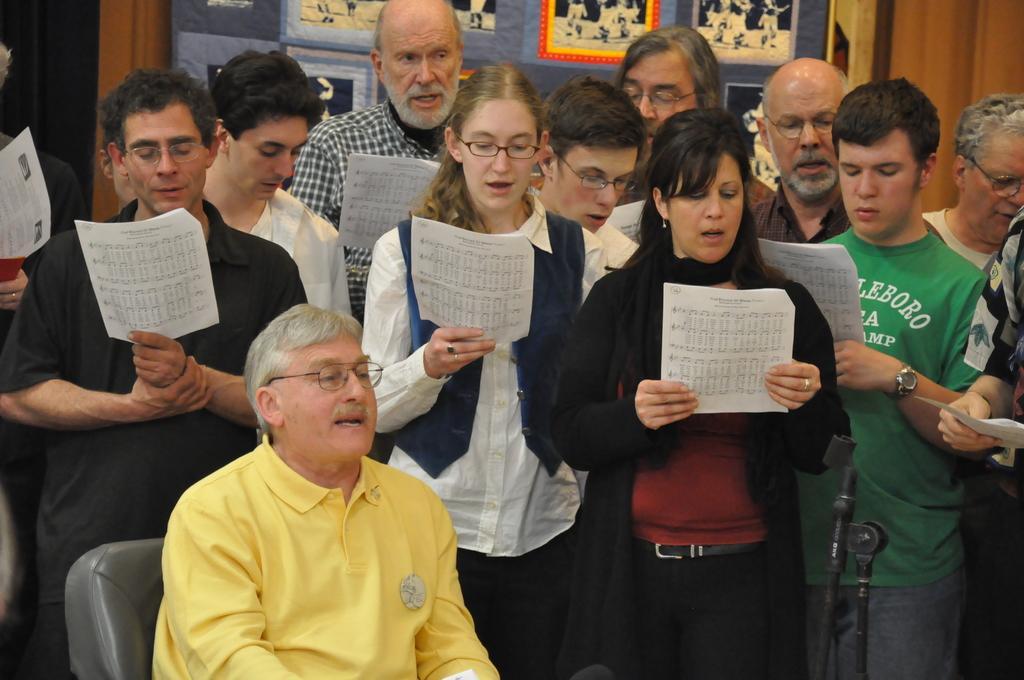Please provide a concise description of this image. In this image, there are a few people. Among them, we can see a person is sitting on a chair. We can see some stands. In the background, we can see some wood. There are a few posts with images. 